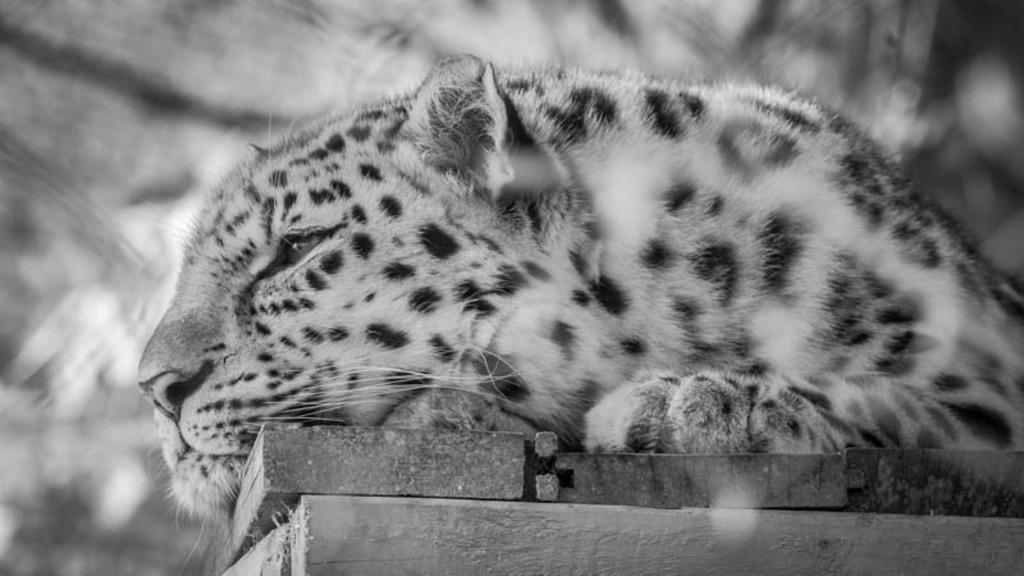What is the color scheme of the image? The image is black and white. What animal is featured in the image? There is a leopard in the image. What is the leopard doing in the image? The leopard is sitting on a surface. Can you describe the background of the image? The background of the image is blurry. How many pies are on the table in the image? There are no pies present in the image; it features a leopard sitting on a surface. What type of marble is visible in the image? There is no marble visible in the image. 